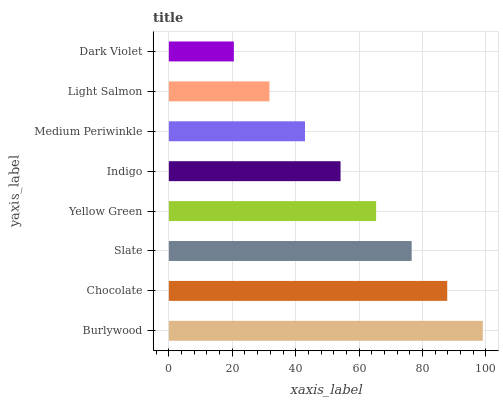Is Dark Violet the minimum?
Answer yes or no. Yes. Is Burlywood the maximum?
Answer yes or no. Yes. Is Chocolate the minimum?
Answer yes or no. No. Is Chocolate the maximum?
Answer yes or no. No. Is Burlywood greater than Chocolate?
Answer yes or no. Yes. Is Chocolate less than Burlywood?
Answer yes or no. Yes. Is Chocolate greater than Burlywood?
Answer yes or no. No. Is Burlywood less than Chocolate?
Answer yes or no. No. Is Yellow Green the high median?
Answer yes or no. Yes. Is Indigo the low median?
Answer yes or no. Yes. Is Burlywood the high median?
Answer yes or no. No. Is Medium Periwinkle the low median?
Answer yes or no. No. 